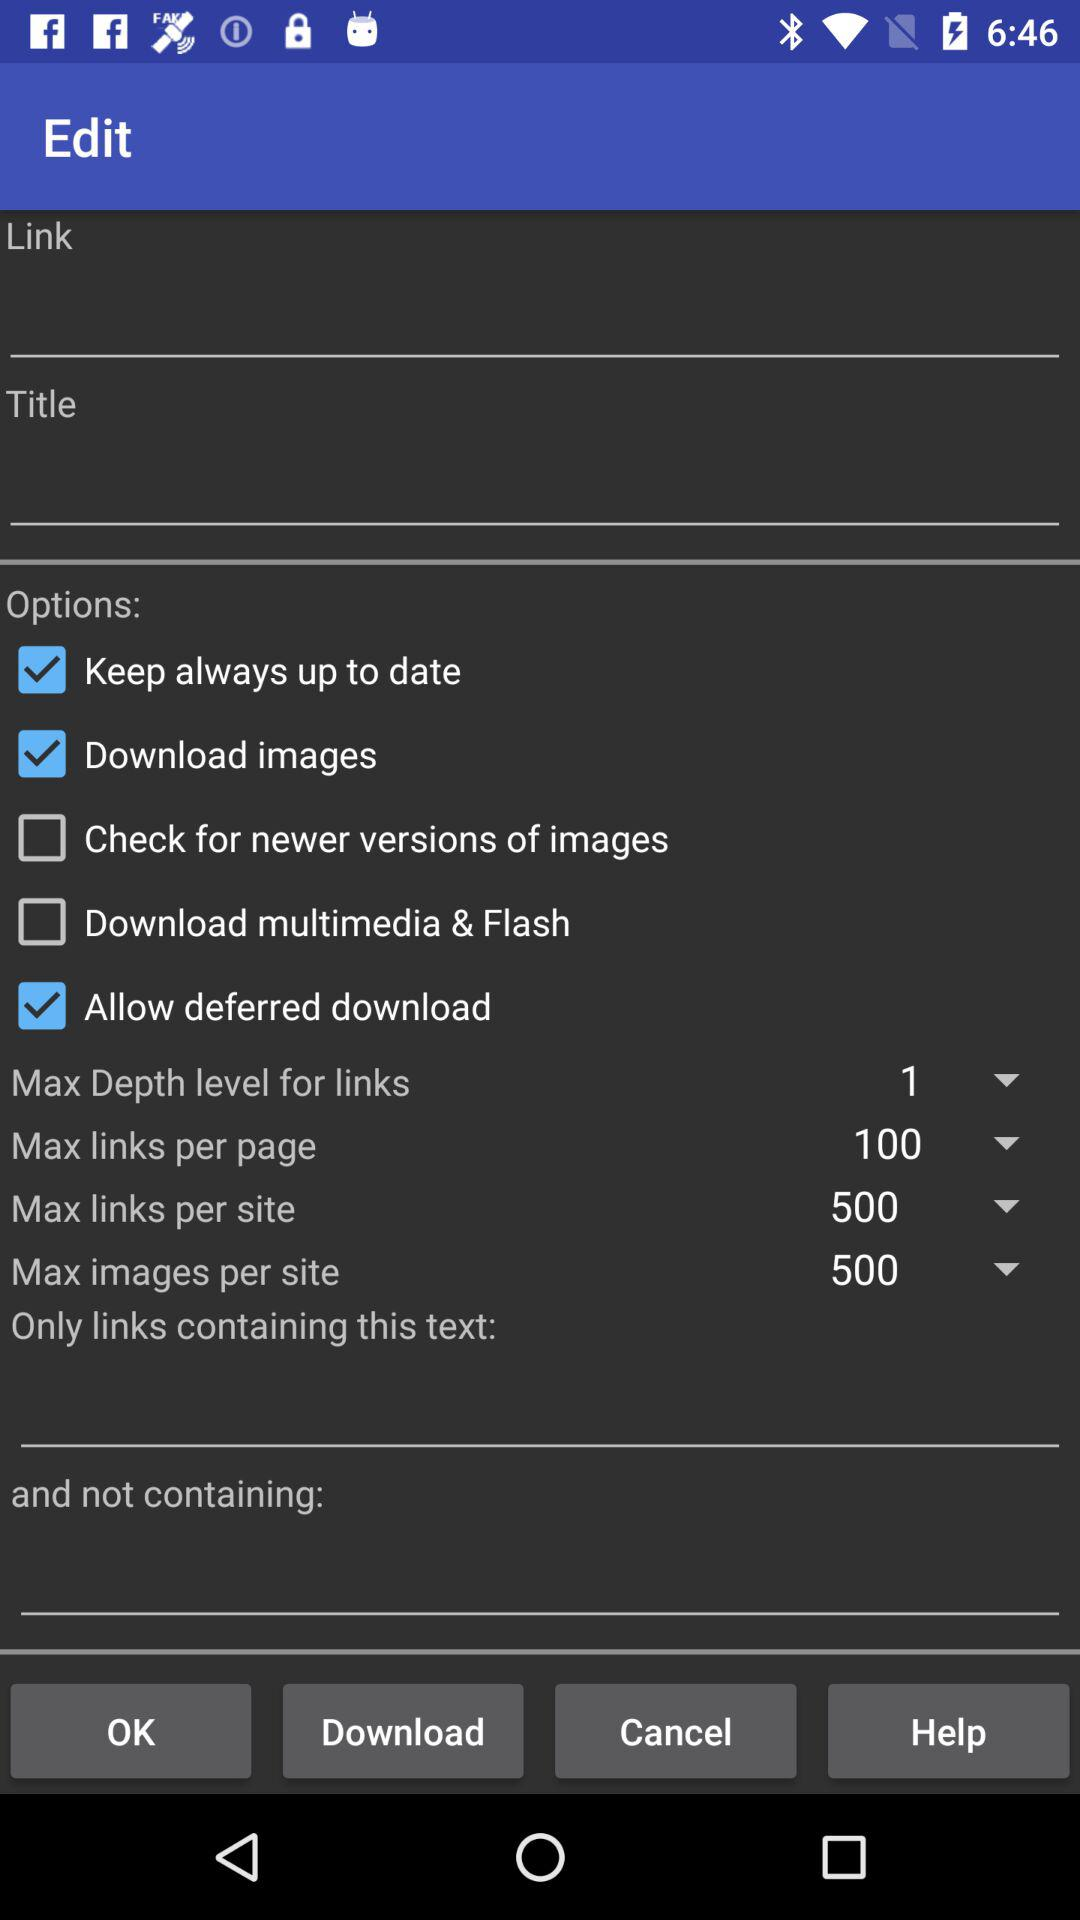What is the maximum number of images per site? The maximum number of images per site is 500. 